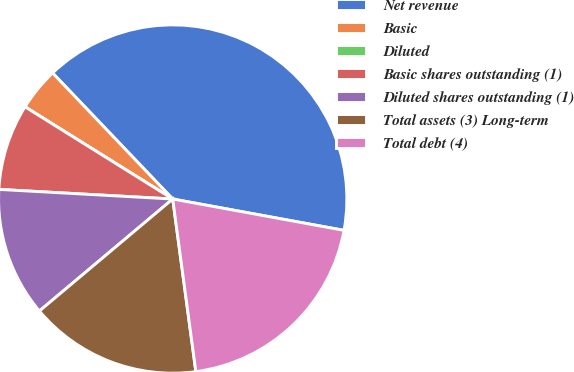Convert chart to OTSL. <chart><loc_0><loc_0><loc_500><loc_500><pie_chart><fcel>Net revenue<fcel>Basic<fcel>Diluted<fcel>Basic shares outstanding (1)<fcel>Diluted shares outstanding (1)<fcel>Total assets (3) Long-term<fcel>Total debt (4)<nl><fcel>40.0%<fcel>4.0%<fcel>0.0%<fcel>8.0%<fcel>12.0%<fcel>16.0%<fcel>20.0%<nl></chart> 